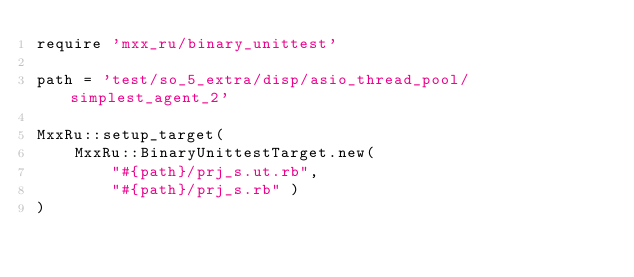<code> <loc_0><loc_0><loc_500><loc_500><_Ruby_>require 'mxx_ru/binary_unittest'

path = 'test/so_5_extra/disp/asio_thread_pool/simplest_agent_2'

MxxRu::setup_target(
	MxxRu::BinaryUnittestTarget.new(
		"#{path}/prj_s.ut.rb",
		"#{path}/prj_s.rb" )
)
</code> 